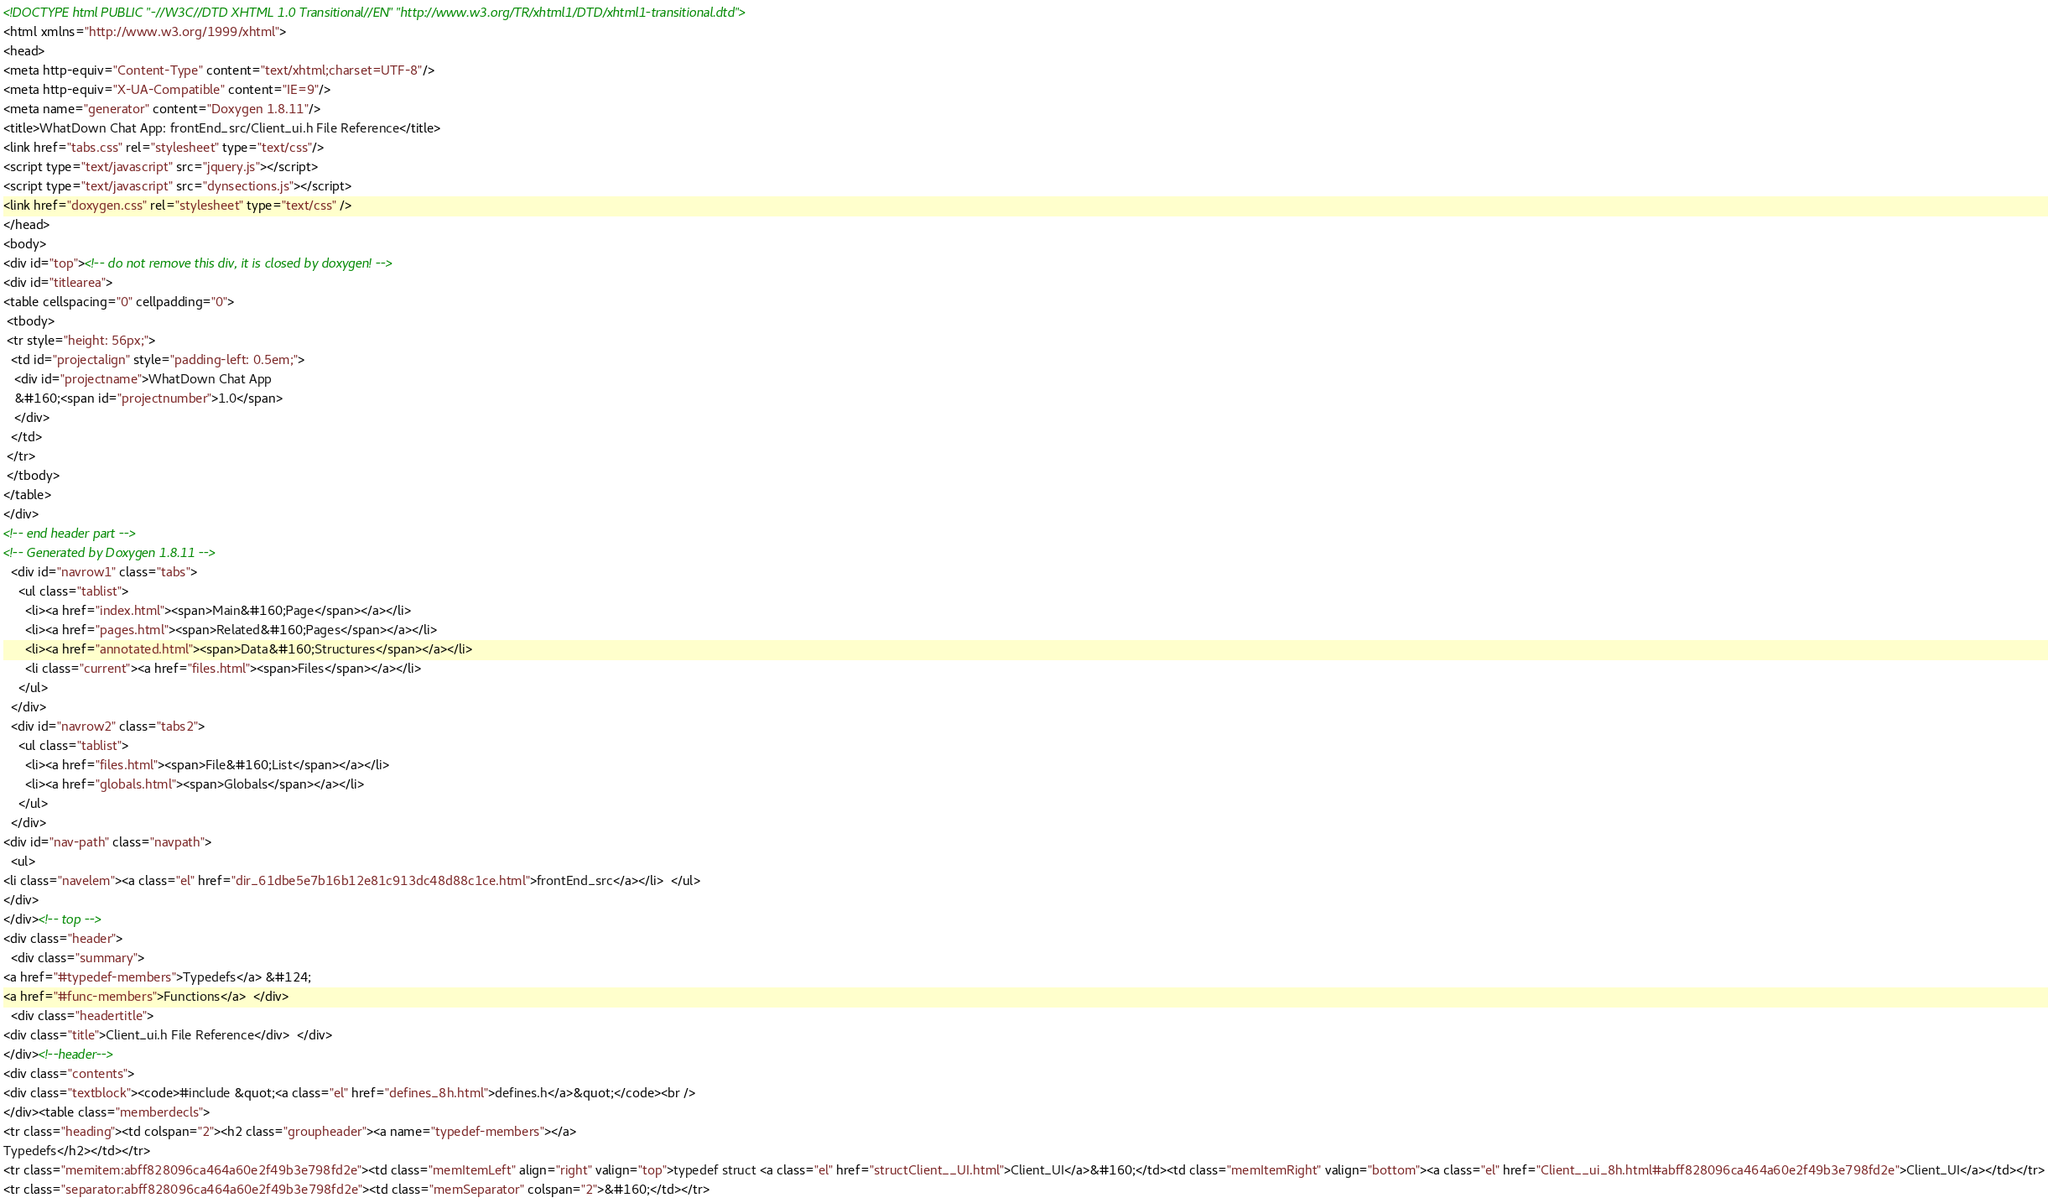Convert code to text. <code><loc_0><loc_0><loc_500><loc_500><_HTML_><!DOCTYPE html PUBLIC "-//W3C//DTD XHTML 1.0 Transitional//EN" "http://www.w3.org/TR/xhtml1/DTD/xhtml1-transitional.dtd">
<html xmlns="http://www.w3.org/1999/xhtml">
<head>
<meta http-equiv="Content-Type" content="text/xhtml;charset=UTF-8"/>
<meta http-equiv="X-UA-Compatible" content="IE=9"/>
<meta name="generator" content="Doxygen 1.8.11"/>
<title>WhatDown Chat App: frontEnd_src/Client_ui.h File Reference</title>
<link href="tabs.css" rel="stylesheet" type="text/css"/>
<script type="text/javascript" src="jquery.js"></script>
<script type="text/javascript" src="dynsections.js"></script>
<link href="doxygen.css" rel="stylesheet" type="text/css" />
</head>
<body>
<div id="top"><!-- do not remove this div, it is closed by doxygen! -->
<div id="titlearea">
<table cellspacing="0" cellpadding="0">
 <tbody>
 <tr style="height: 56px;">
  <td id="projectalign" style="padding-left: 0.5em;">
   <div id="projectname">WhatDown Chat App
   &#160;<span id="projectnumber">1.0</span>
   </div>
  </td>
 </tr>
 </tbody>
</table>
</div>
<!-- end header part -->
<!-- Generated by Doxygen 1.8.11 -->
  <div id="navrow1" class="tabs">
    <ul class="tablist">
      <li><a href="index.html"><span>Main&#160;Page</span></a></li>
      <li><a href="pages.html"><span>Related&#160;Pages</span></a></li>
      <li><a href="annotated.html"><span>Data&#160;Structures</span></a></li>
      <li class="current"><a href="files.html"><span>Files</span></a></li>
    </ul>
  </div>
  <div id="navrow2" class="tabs2">
    <ul class="tablist">
      <li><a href="files.html"><span>File&#160;List</span></a></li>
      <li><a href="globals.html"><span>Globals</span></a></li>
    </ul>
  </div>
<div id="nav-path" class="navpath">
  <ul>
<li class="navelem"><a class="el" href="dir_61dbe5e7b16b12e81c913dc48d88c1ce.html">frontEnd_src</a></li>  </ul>
</div>
</div><!-- top -->
<div class="header">
  <div class="summary">
<a href="#typedef-members">Typedefs</a> &#124;
<a href="#func-members">Functions</a>  </div>
  <div class="headertitle">
<div class="title">Client_ui.h File Reference</div>  </div>
</div><!--header-->
<div class="contents">
<div class="textblock"><code>#include &quot;<a class="el" href="defines_8h.html">defines.h</a>&quot;</code><br />
</div><table class="memberdecls">
<tr class="heading"><td colspan="2"><h2 class="groupheader"><a name="typedef-members"></a>
Typedefs</h2></td></tr>
<tr class="memitem:abff828096ca464a60e2f49b3e798fd2e"><td class="memItemLeft" align="right" valign="top">typedef struct <a class="el" href="structClient__UI.html">Client_UI</a>&#160;</td><td class="memItemRight" valign="bottom"><a class="el" href="Client__ui_8h.html#abff828096ca464a60e2f49b3e798fd2e">Client_UI</a></td></tr>
<tr class="separator:abff828096ca464a60e2f49b3e798fd2e"><td class="memSeparator" colspan="2">&#160;</td></tr></code> 